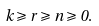Convert formula to latex. <formula><loc_0><loc_0><loc_500><loc_500>k \geqslant r \geqslant n \geqslant 0 .</formula> 